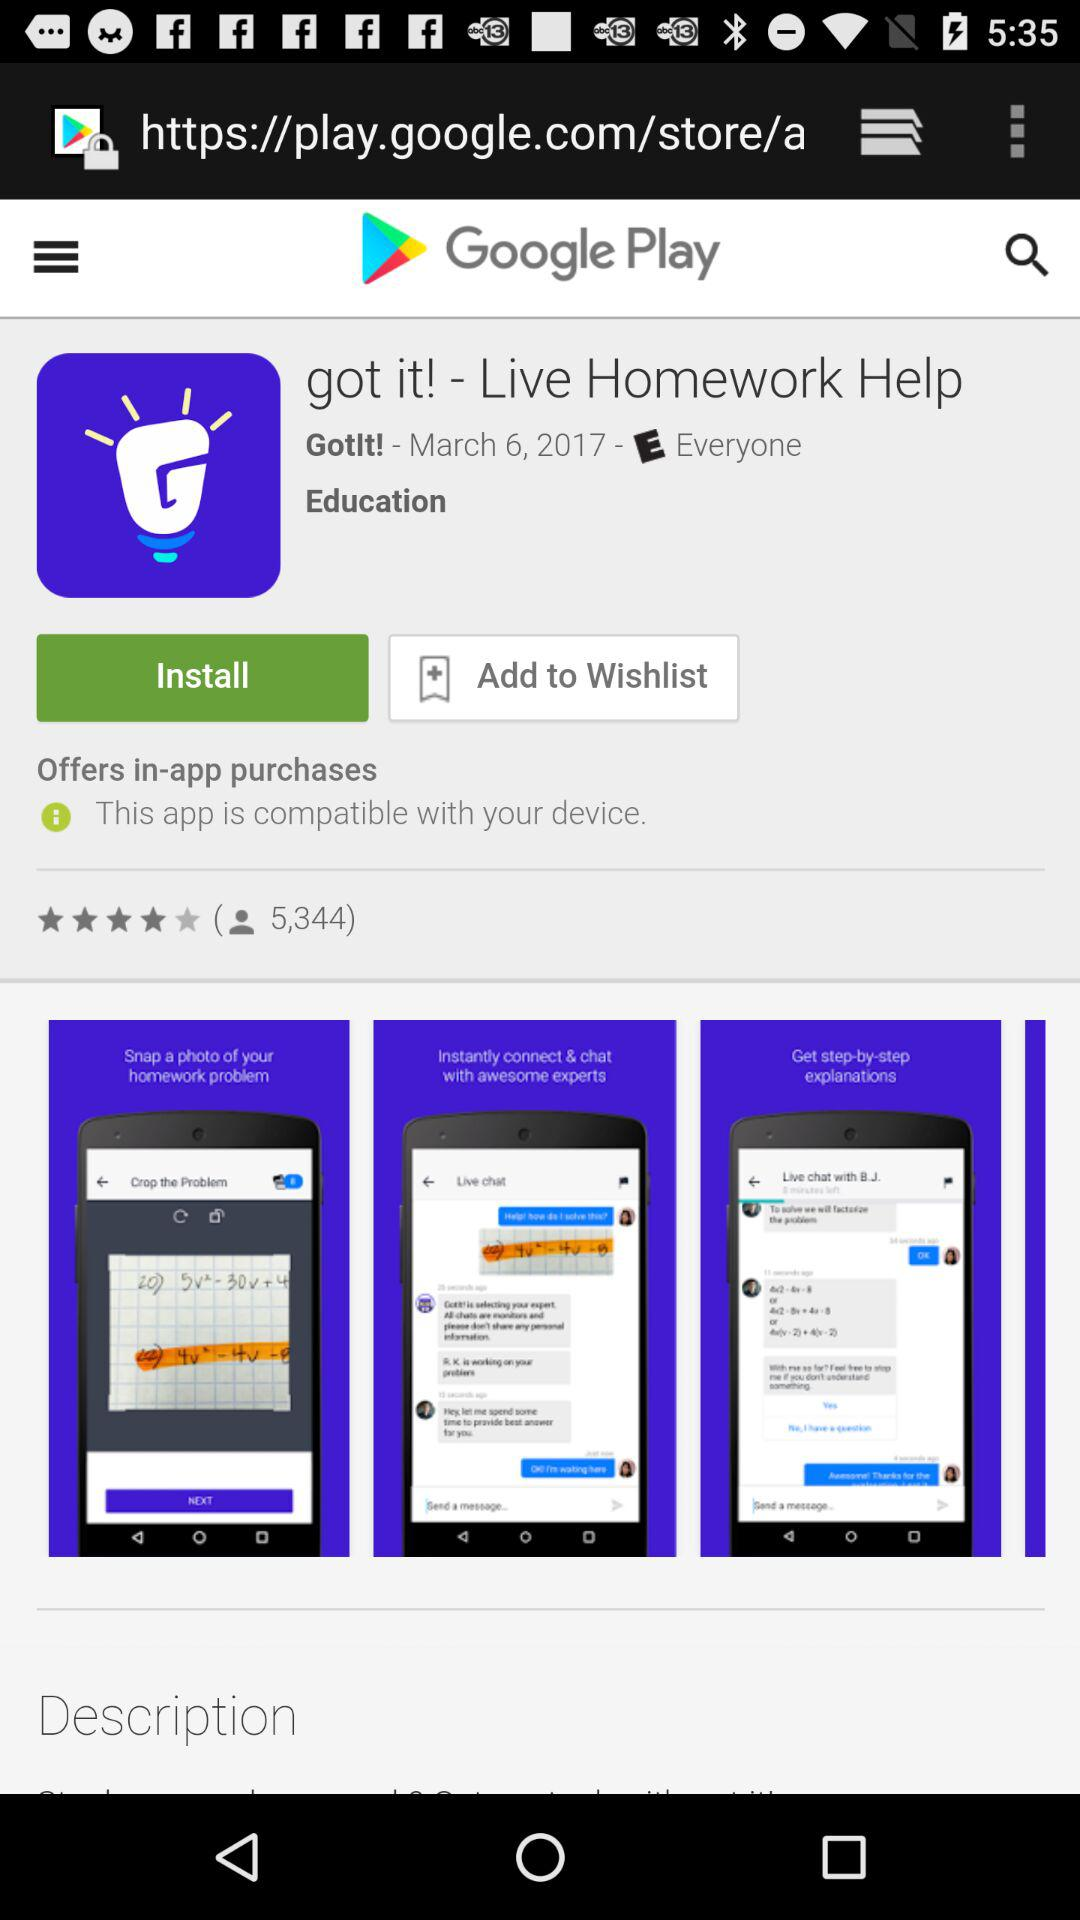What is the application name? The application name is "got it!". 